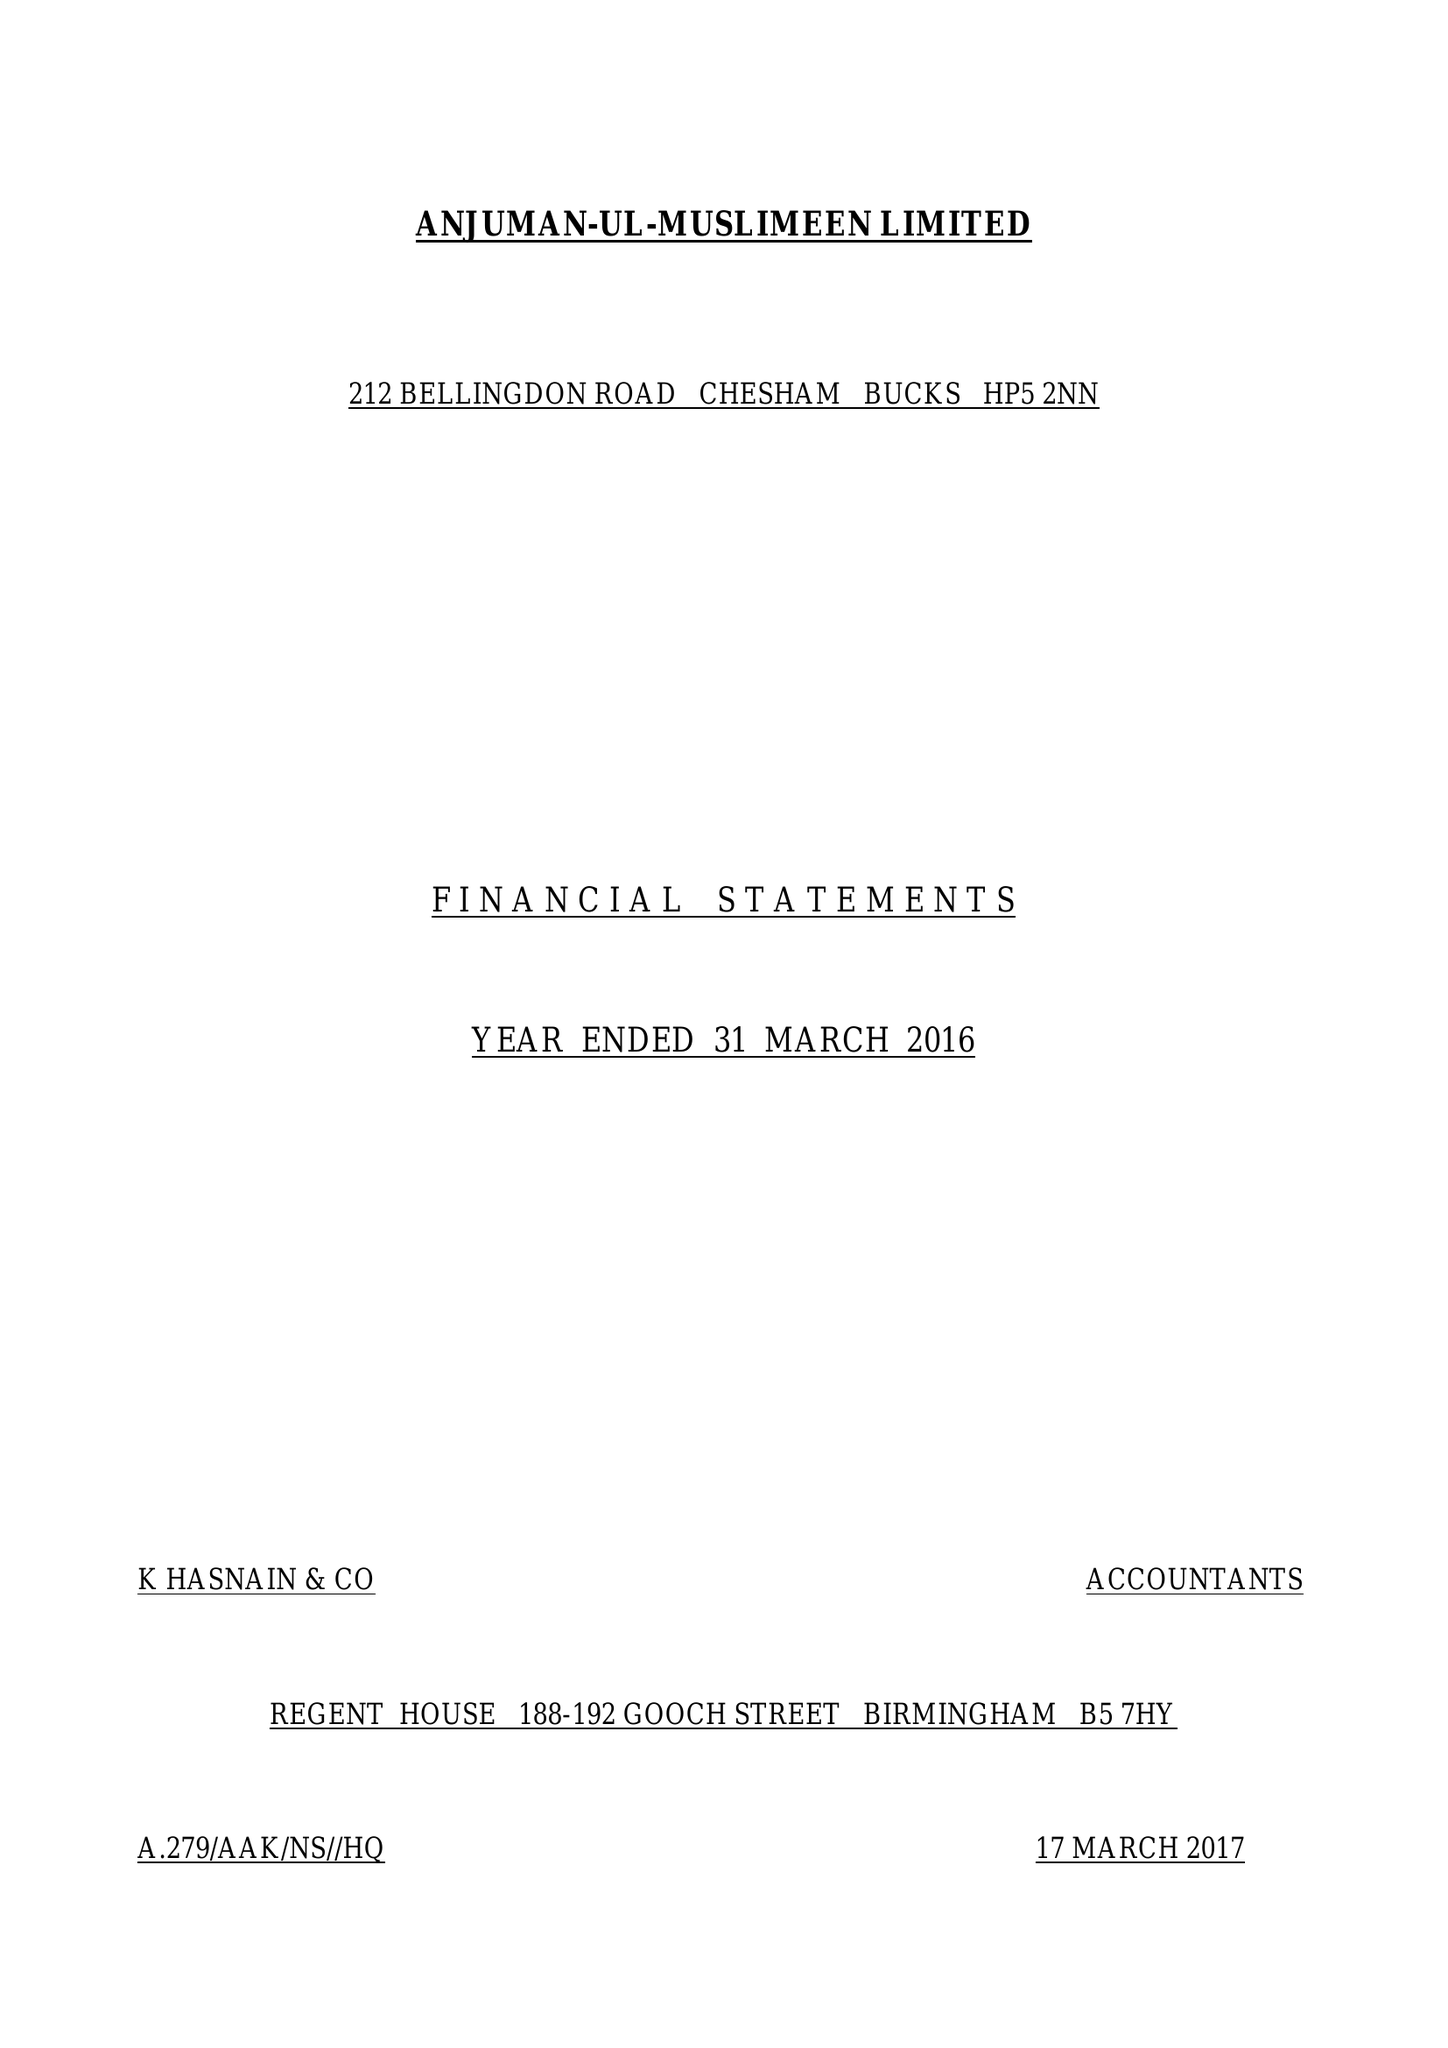What is the value for the income_annually_in_british_pounds?
Answer the question using a single word or phrase. 76542.00 